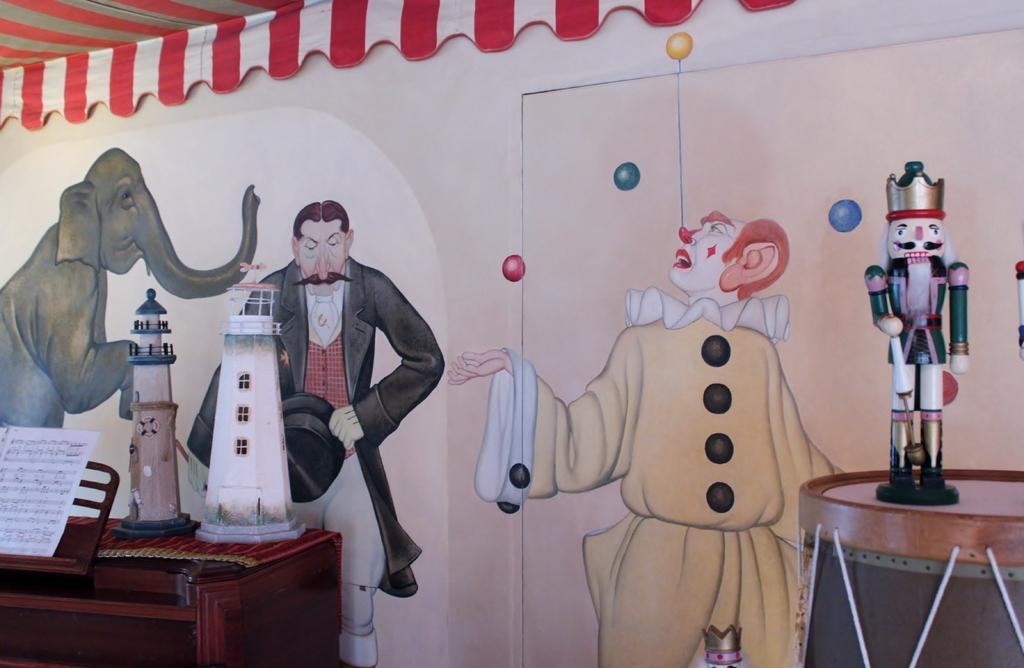What type of objects are on the table in the image? There are two toy buildings and a book on the table in the image. Can you describe the toy on the drum? There is a toy on a drum in the image. What can be seen on the wall in the background? There are pictures painted on the wall in the background. What type of hat is the judge wearing in the image? There is no judge or hat present in the image. Can you tell me the color of the kitty's fur in the image? There is no kitty present in the image. 